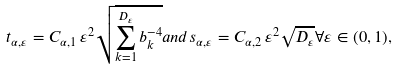<formula> <loc_0><loc_0><loc_500><loc_500>t _ { \alpha , \varepsilon } = C _ { \alpha , 1 } \, \varepsilon ^ { 2 } \sqrt { \sum _ { k = 1 } ^ { D _ { \varepsilon } } b _ { k } ^ { - 4 } } a n d s _ { \alpha , \varepsilon } = C _ { \alpha , 2 } \, \varepsilon ^ { 2 } \sqrt { D _ { \varepsilon } } \forall \varepsilon \in ( 0 , 1 ) ,</formula> 